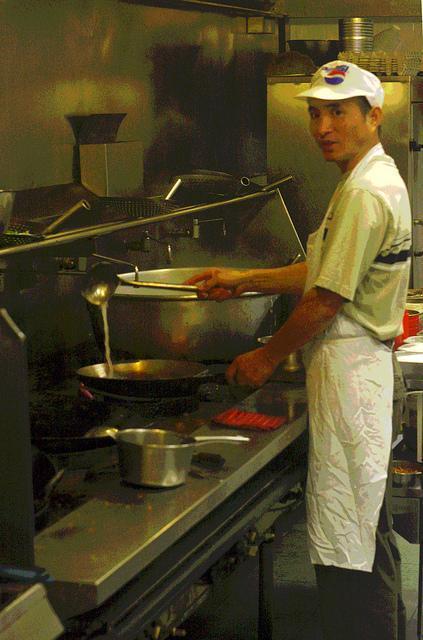What style food is most likely being prepared in this kitchen?
Indicate the correct choice and explain in the format: 'Answer: answer
Rationale: rationale.'
Options: Baked goods, mexican, italian, chinese. Answer: chinese.
Rationale: Some chinese food served in restaurants are typically cooked in a wok, which is shown to be used by the chef here. 